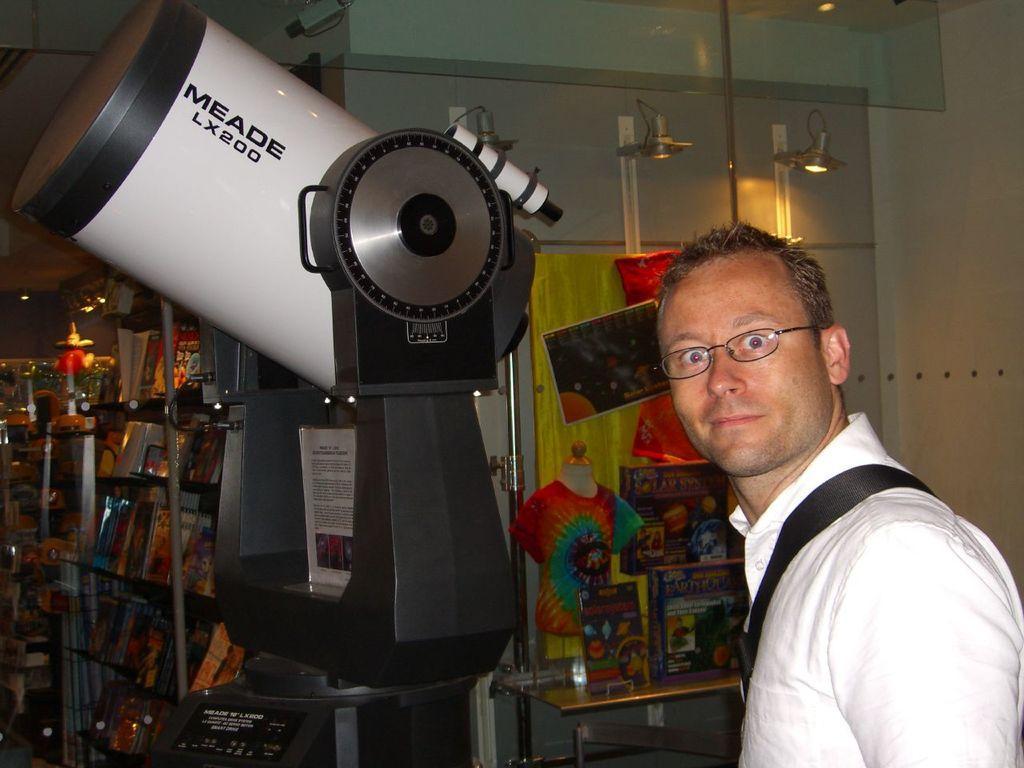How would you summarize this image in a sentence or two? In this picture I can see a man with spectacles, there is a telescope, there are boards, books, lights and some other objects. 